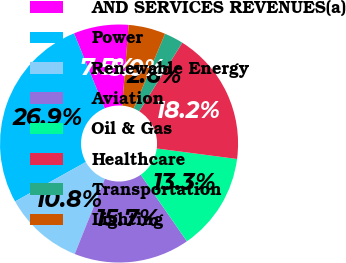<chart> <loc_0><loc_0><loc_500><loc_500><pie_chart><fcel>AND SERVICES REVENUES(a)<fcel>Power<fcel>Renewable Energy<fcel>Aviation<fcel>Oil & Gas<fcel>Healthcare<fcel>Transportation<fcel>Lighting<nl><fcel>7.46%<fcel>26.92%<fcel>10.84%<fcel>15.73%<fcel>13.27%<fcel>18.16%<fcel>2.6%<fcel>5.03%<nl></chart> 